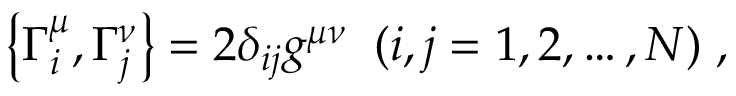Convert formula to latex. <formula><loc_0><loc_0><loc_500><loc_500>\left \{ \Gamma _ { i } ^ { \mu } , \Gamma _ { j } ^ { \nu } \right \} = 2 \delta _ { i j } g ^ { \mu \nu } \, ( i , j = 1 , 2 , \dots , N ) \, ,</formula> 